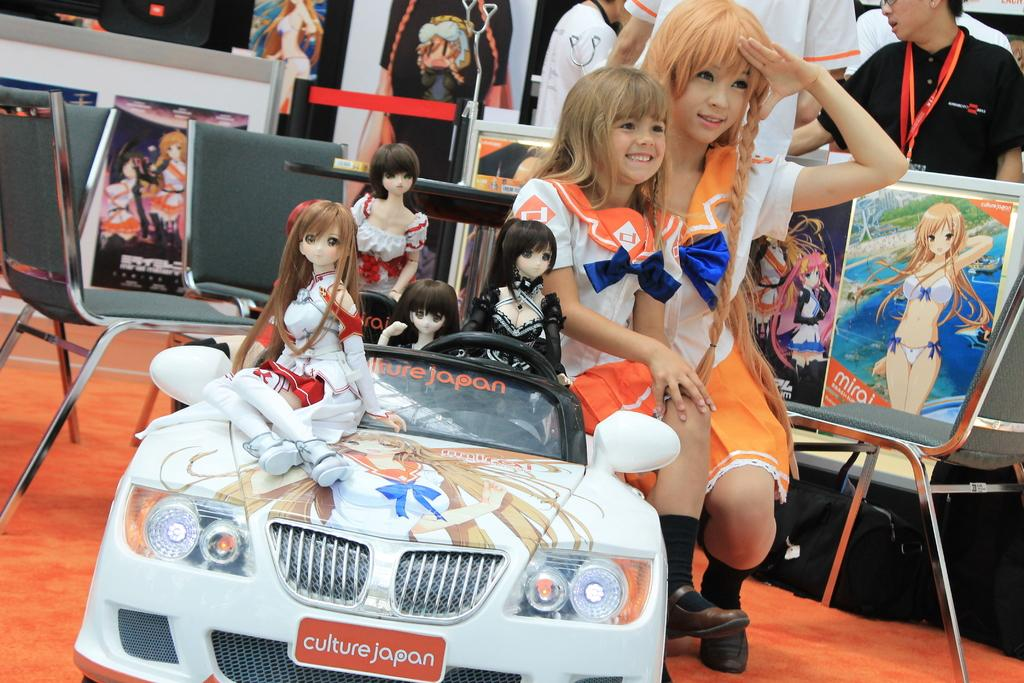How many girls are in the image? There are two girls in the image. What are the girls doing in the image? The girls are sitting on toy vehicles. What is unique about the toy vehicles? The toy vehicles have toy girls on them. What furniture is present in the image? There is a chair and a table in the image. What type of decorations are visible in the image? There are posters in the image. Who else is present in the image besides the girls? There is a woman in the image. What type of plants can be seen growing on the table in the image? There are no plants visible on the table in the image. What type of music is being played in the background of the image? There is no indication of music being played in the image. 